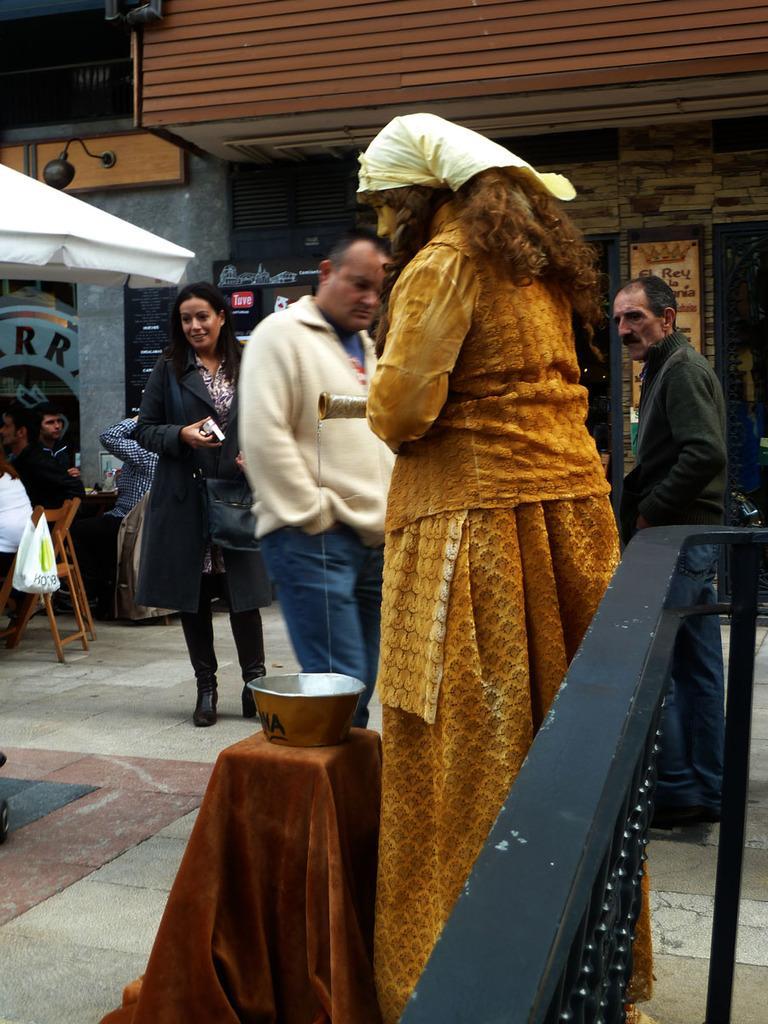Please provide a concise description of this image. In this image I can see few people. There are chairs and there is a bowl on an object. Also there is a grille and in the background there are buildings. 